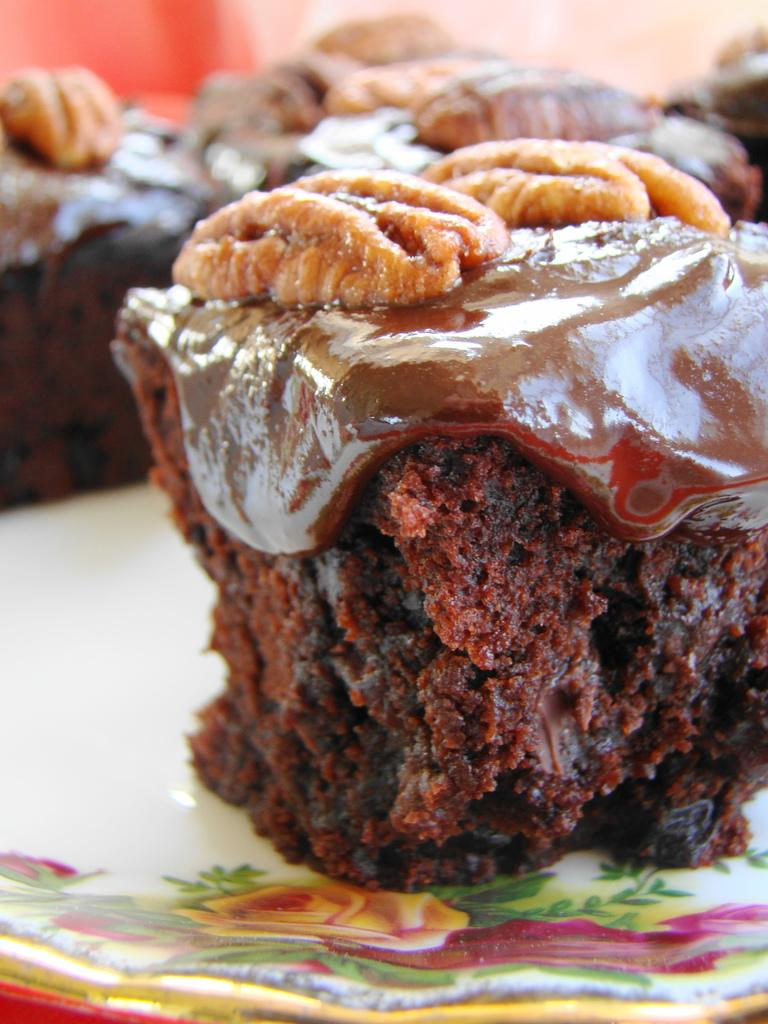What type of dessert is on the plate in the image? There is a chocolate cake on a plate in the image. Can you describe the background of the image? The background of the image is slightly blurred. What else can be seen in the background of the image? There are more pieces of chocolate cake visible in the blurred background. In which direction is the fish swimming in the image? There is no fish present in the image. 